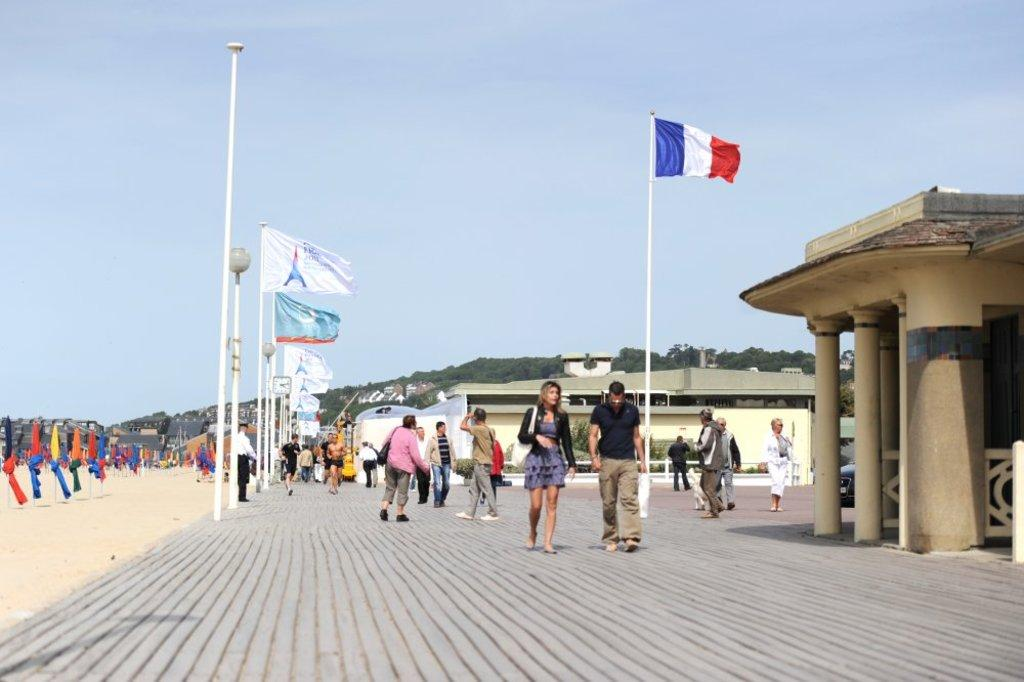What are the people in the image doing? The people in the image are standing on the footpath. What can be seen attached to the pole in the image? There are flags tied to a pole in the image. What type of structures can be seen in the image? There are buildings visible in the image. What type of terrain is visible on one side of the image? There is sand on one side of the image. How much sugar is being used by the people standing on the footpath? There is no mention of sugar or its use in the image, so it cannot be determined. What type of gate can be seen in the image? There is no gate present in the image. 